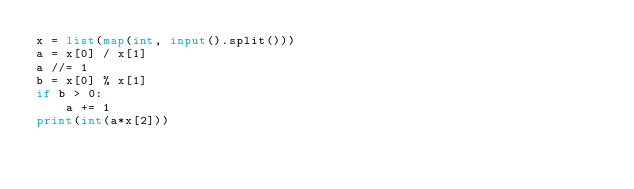<code> <loc_0><loc_0><loc_500><loc_500><_Python_>x = list(map(int, input().split()))
a = x[0] / x[1]
a //= 1
b = x[0] % x[1]
if b > 0:
    a += 1
print(int(a*x[2]))</code> 